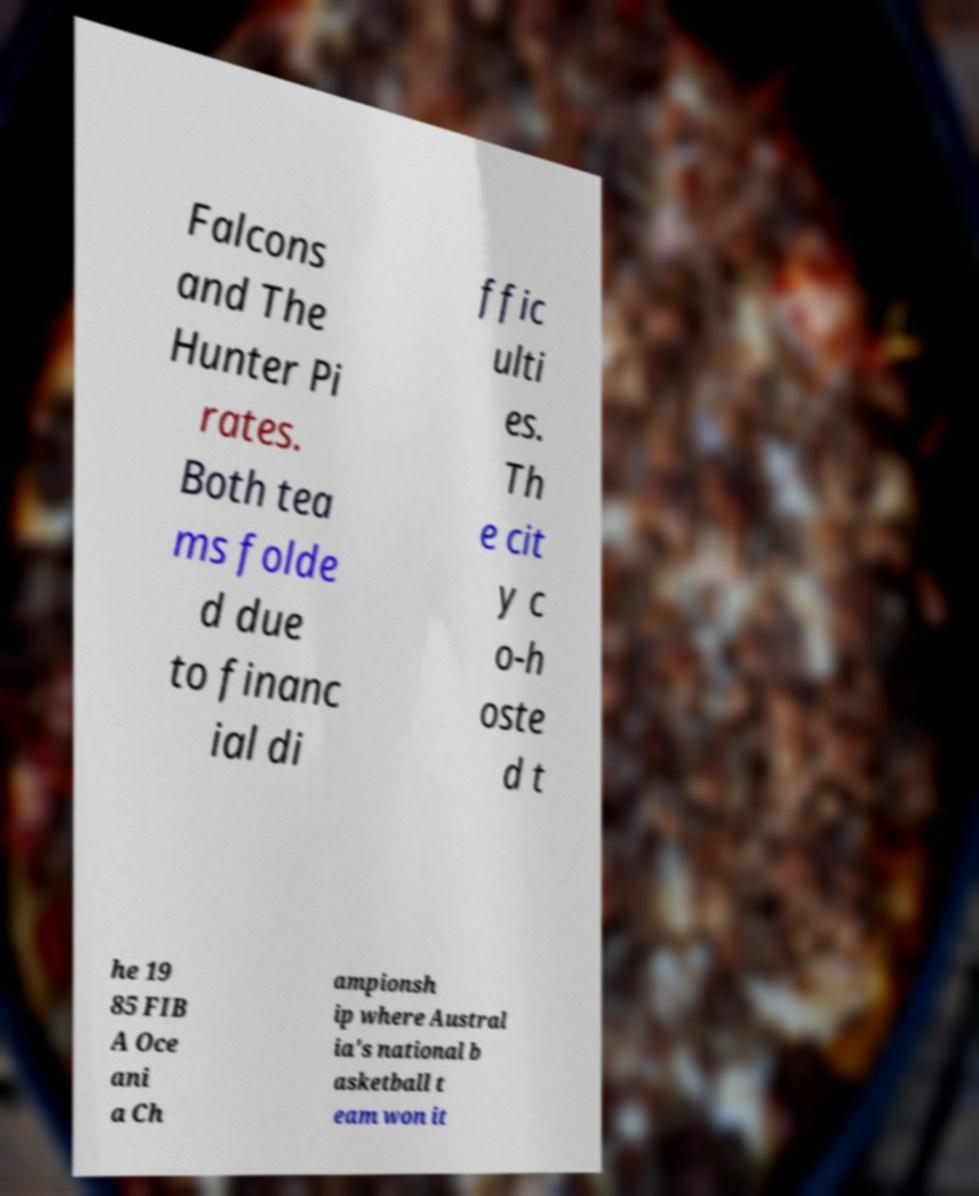What messages or text are displayed in this image? I need them in a readable, typed format. Falcons and The Hunter Pi rates. Both tea ms folde d due to financ ial di ffic ulti es. Th e cit y c o-h oste d t he 19 85 FIB A Oce ani a Ch ampionsh ip where Austral ia's national b asketball t eam won it 